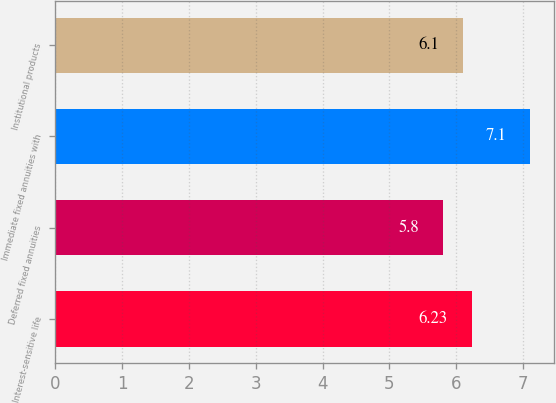Convert chart. <chart><loc_0><loc_0><loc_500><loc_500><bar_chart><fcel>Interest-sensitive life<fcel>Deferred fixed annuities<fcel>Immediate fixed annuities with<fcel>Institutional products<nl><fcel>6.23<fcel>5.8<fcel>7.1<fcel>6.1<nl></chart> 